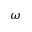Convert formula to latex. <formula><loc_0><loc_0><loc_500><loc_500>\omega</formula> 